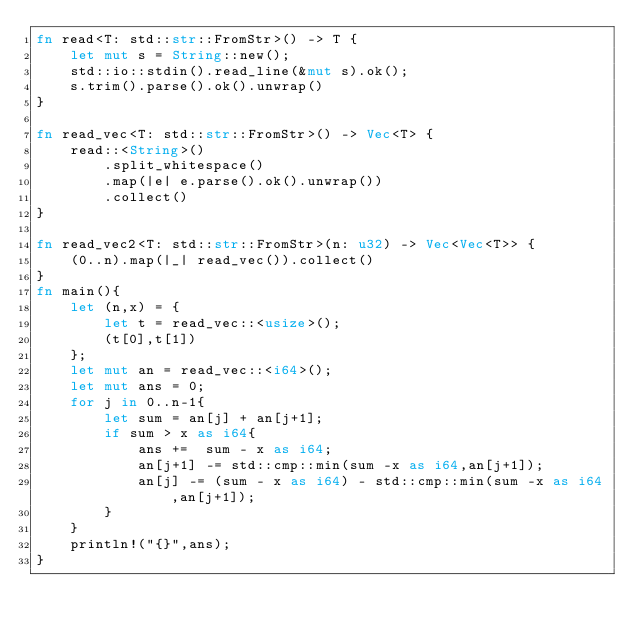<code> <loc_0><loc_0><loc_500><loc_500><_Rust_>fn read<T: std::str::FromStr>() -> T {
    let mut s = String::new();
    std::io::stdin().read_line(&mut s).ok();
    s.trim().parse().ok().unwrap()
}

fn read_vec<T: std::str::FromStr>() -> Vec<T> {
    read::<String>()
        .split_whitespace()
        .map(|e| e.parse().ok().unwrap())
        .collect()
}

fn read_vec2<T: std::str::FromStr>(n: u32) -> Vec<Vec<T>> {
    (0..n).map(|_| read_vec()).collect()
}
fn main(){
    let (n,x) = {
        let t = read_vec::<usize>();
        (t[0],t[1])
    };
    let mut an = read_vec::<i64>();
    let mut ans = 0;
    for j in 0..n-1{
        let sum = an[j] + an[j+1];
        if sum > x as i64{
            ans +=  sum - x as i64;
            an[j+1] -= std::cmp::min(sum -x as i64,an[j+1]);
            an[j] -= (sum - x as i64) - std::cmp::min(sum -x as i64,an[j+1]);
        }
    }
    println!("{}",ans);
}
</code> 